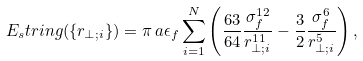<formula> <loc_0><loc_0><loc_500><loc_500>E _ { s } t r i n g ( \{ r _ { \perp ; i } \} ) = \pi \, a \epsilon _ { f } \sum _ { i = 1 } ^ { N } \left ( \frac { 6 3 } { 6 4 } \frac { \sigma _ { f } ^ { 1 2 } } { r _ { \perp ; i } ^ { 1 1 } } - \frac { 3 } { 2 } \frac { \sigma _ { f } ^ { 6 } } { r _ { \perp ; i } ^ { 5 } } \right ) ,</formula> 